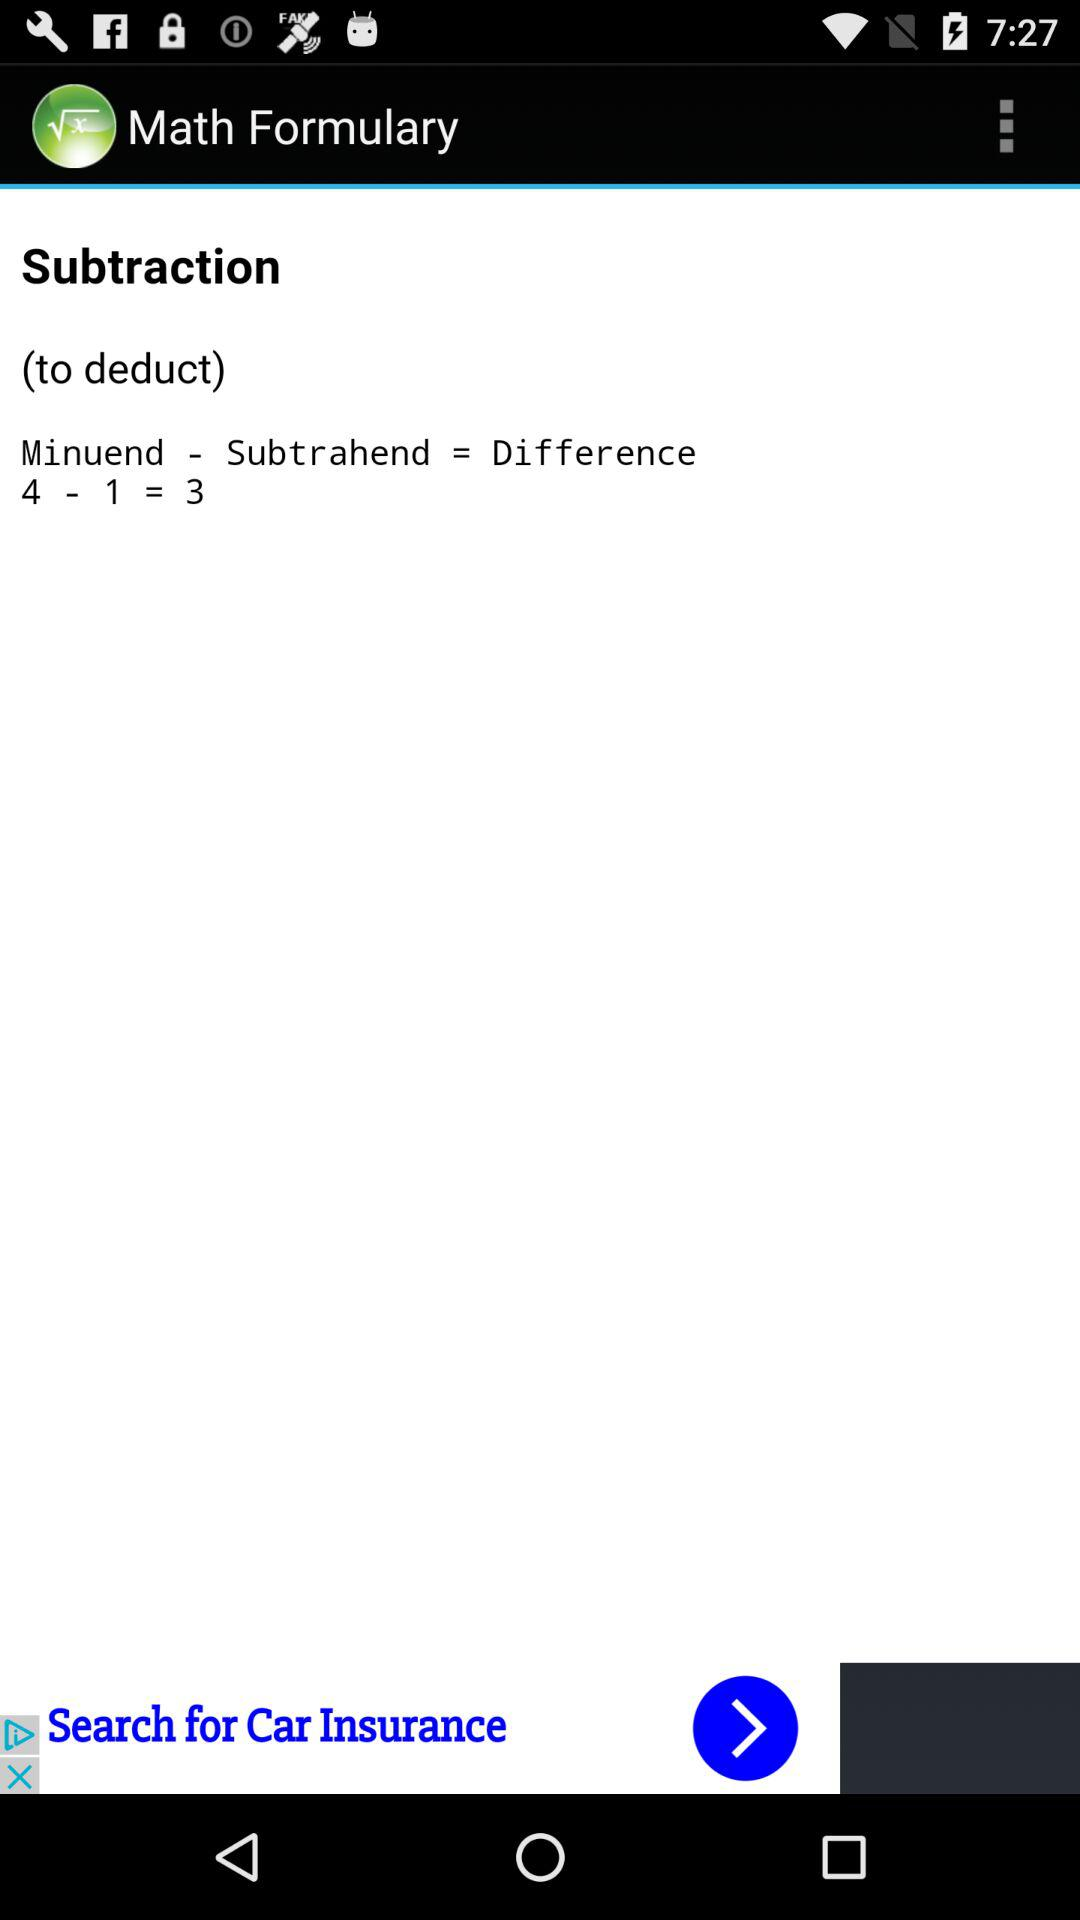What is the sum of the minuend and subtrahend?
Answer the question using a single word or phrase. 5 